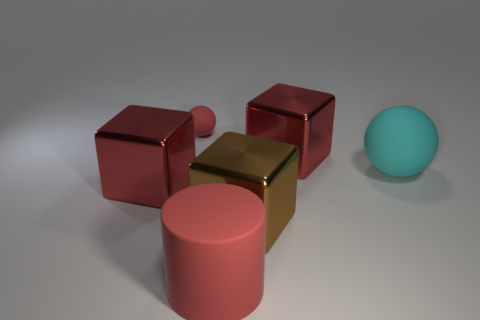Subtract all purple spheres. How many red cubes are left? 2 Add 1 rubber cylinders. How many objects exist? 7 Subtract all big brown blocks. How many blocks are left? 2 Subtract 1 cubes. How many cubes are left? 2 Subtract all cylinders. How many objects are left? 5 Subtract all tiny yellow blocks. Subtract all red cubes. How many objects are left? 4 Add 2 red cylinders. How many red cylinders are left? 3 Add 3 large spheres. How many large spheres exist? 4 Subtract 1 brown cubes. How many objects are left? 5 